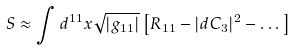<formula> <loc_0><loc_0><loc_500><loc_500>S \approx \int d ^ { 1 1 } x \sqrt { | g _ { 1 1 } | } \left [ R _ { 1 1 } - | d C _ { 3 } | ^ { 2 } - \dots \right ]</formula> 